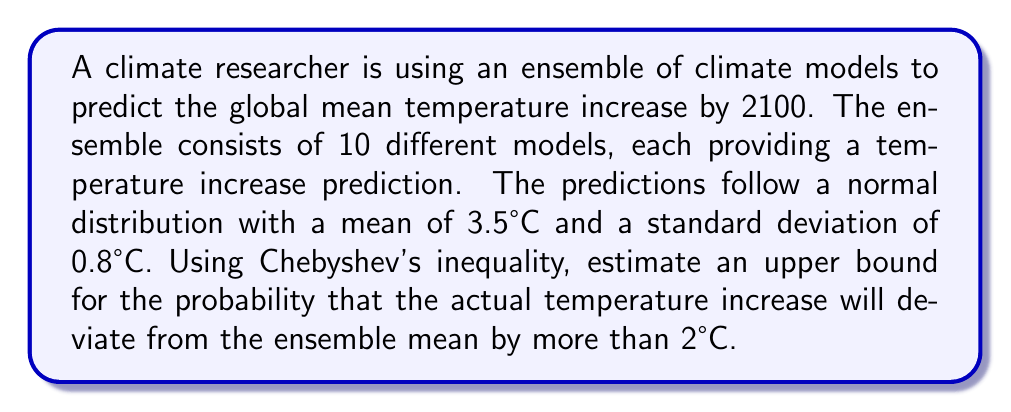Help me with this question. To solve this problem, we'll use Chebyshev's inequality, which states that for a random variable $X$ with mean $\mu$ and standard deviation $\sigma$, and for any $k > 0$:

$$P(|X - \mu| \geq k\sigma) \leq \frac{1}{k^2}$$

In our case:
- $\mu = 3.5°C$ (ensemble mean)
- $\sigma = 0.8°C$ (ensemble standard deviation)
- We want to find the probability of deviating by more than 2°C, so $|X - \mu| \geq 2$

First, we need to express the deviation in terms of standard deviations:

$$\frac{2}{\sigma} = \frac{2}{0.8} = 2.5$$

So, we're looking for $P(|X - \mu| \geq 2.5\sigma)$

Now we can apply Chebyshev's inequality with $k = 2.5$:

$$P(|X - \mu| \geq 2.5\sigma) \leq \frac{1}{(2.5)^2} = \frac{1}{6.25} = 0.16$$

Therefore, the upper bound for the probability that the actual temperature increase will deviate from the ensemble mean by more than 2°C is 0.16 or 16%.
Answer: The upper bound for the probability that the actual temperature increase will deviate from the ensemble mean by more than 2°C is 0.16 or 16%. 